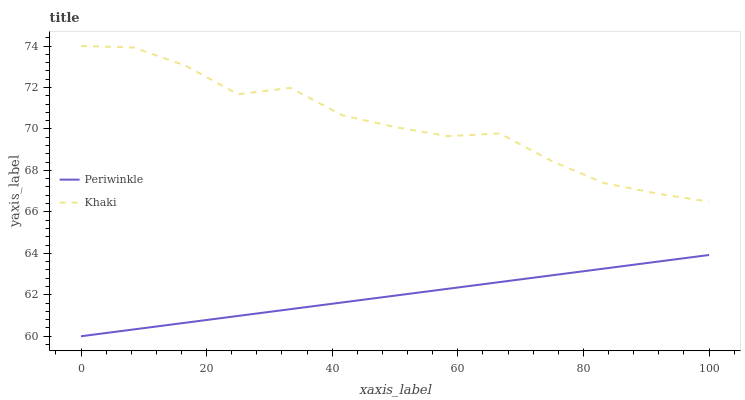Does Periwinkle have the minimum area under the curve?
Answer yes or no. Yes. Does Khaki have the maximum area under the curve?
Answer yes or no. Yes. Does Periwinkle have the maximum area under the curve?
Answer yes or no. No. Is Periwinkle the smoothest?
Answer yes or no. Yes. Is Khaki the roughest?
Answer yes or no. Yes. Is Periwinkle the roughest?
Answer yes or no. No. Does Periwinkle have the lowest value?
Answer yes or no. Yes. Does Khaki have the highest value?
Answer yes or no. Yes. Does Periwinkle have the highest value?
Answer yes or no. No. Is Periwinkle less than Khaki?
Answer yes or no. Yes. Is Khaki greater than Periwinkle?
Answer yes or no. Yes. Does Periwinkle intersect Khaki?
Answer yes or no. No. 